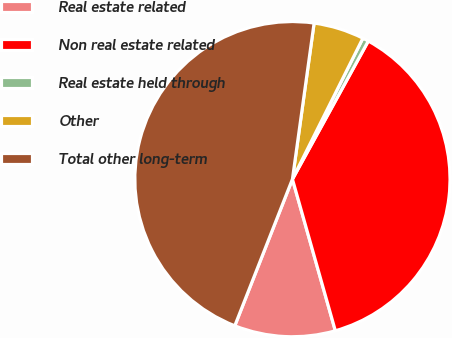Convert chart to OTSL. <chart><loc_0><loc_0><loc_500><loc_500><pie_chart><fcel>Real estate related<fcel>Non real estate related<fcel>Real estate held through<fcel>Other<fcel>Total other long-term<nl><fcel>10.35%<fcel>37.61%<fcel>0.62%<fcel>5.18%<fcel>46.23%<nl></chart> 